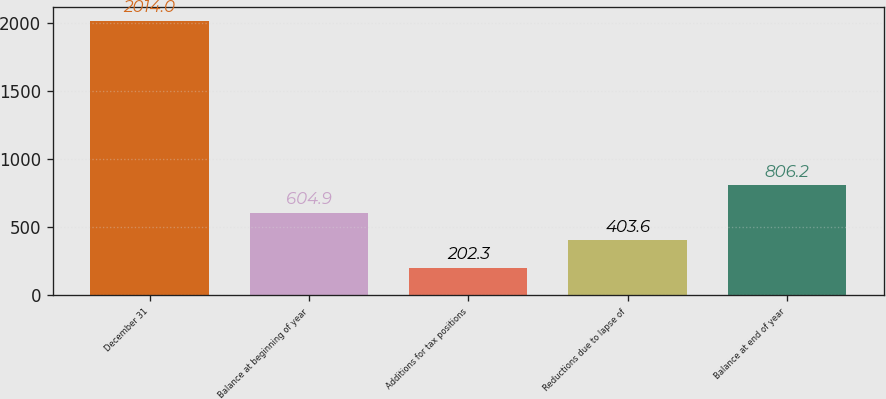Convert chart to OTSL. <chart><loc_0><loc_0><loc_500><loc_500><bar_chart><fcel>December 31<fcel>Balance at beginning of year<fcel>Additions for tax positions<fcel>Reductions due to lapse of<fcel>Balance at end of year<nl><fcel>2014<fcel>604.9<fcel>202.3<fcel>403.6<fcel>806.2<nl></chart> 